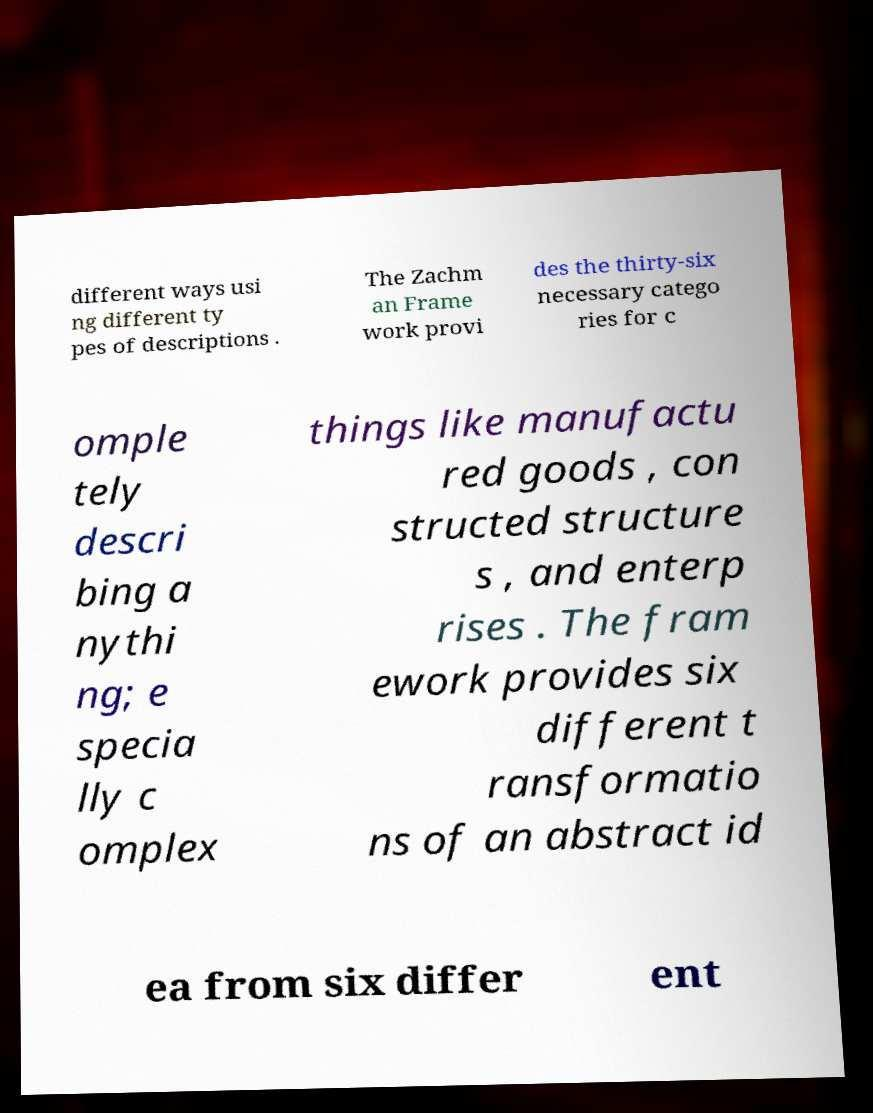I need the written content from this picture converted into text. Can you do that? different ways usi ng different ty pes of descriptions . The Zachm an Frame work provi des the thirty-six necessary catego ries for c omple tely descri bing a nythi ng; e specia lly c omplex things like manufactu red goods , con structed structure s , and enterp rises . The fram ework provides six different t ransformatio ns of an abstract id ea from six differ ent 